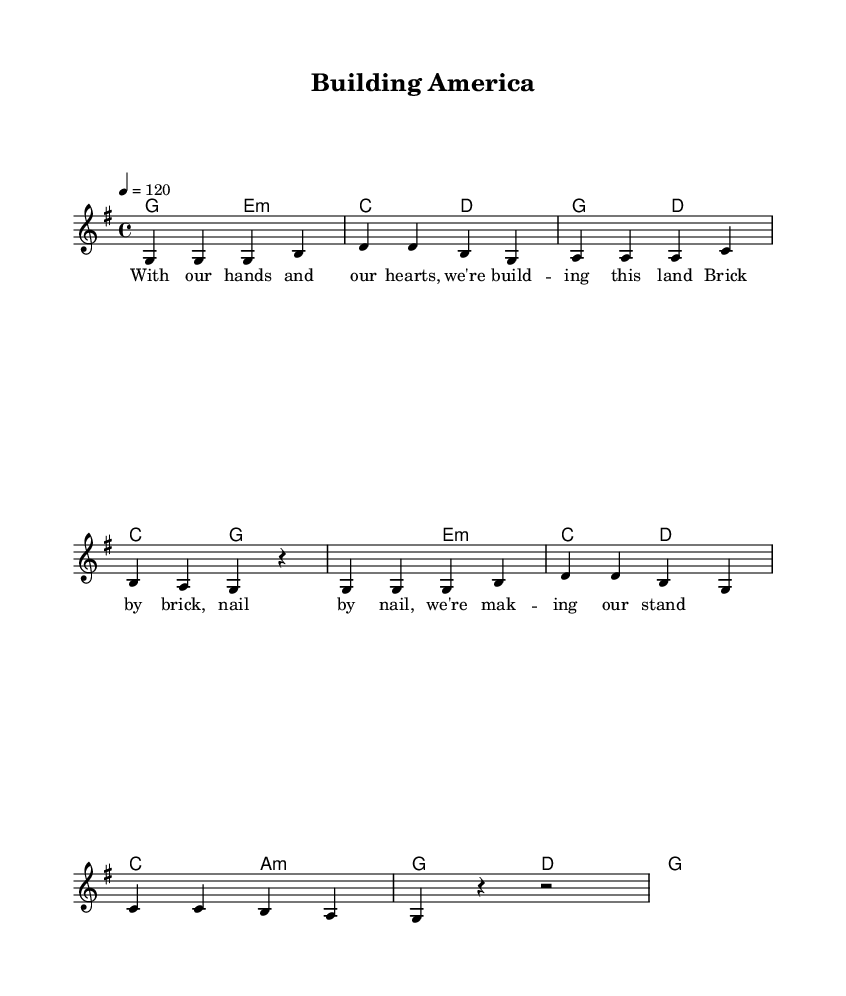What is the key signature of this music? The key signature is G major, which has one sharp (F#). This can be observed in the initial section of the sheet music where G major is indicated.
Answer: G major What is the time signature of this music? The time signature is 4/4, which means there are four beats in each measure (bar) and the quarter note gets one beat. This can be seen at the beginning of the score, specifically in the part where “\time 4/4” is stated.
Answer: 4/4 What is the tempo marking indicated in this music? The tempo marking is 120 beats per minute, as seen in the section stating “\tempo 4 = 120,” which indicates the speed of the piece.
Answer: 120 How many measures are there in the melody? There are 8 measures in the melody, as counted from the beginning of the melody notation until the end. Each measure is divided by vertical lines.
Answer: 8 What is the first chord in the harmony? The first chord in the harmony is G major, which is shown in the first part of the harmony section denoted as “g2” that signifies the G major chord.
Answer: G major What is the lyrical theme of the song? The theme celebrates craftsmanship and hard work in building the country, as seen in the lyrics “With our hands and our hearts, we're building this land.” This reflects the essence of the song's message.
Answer: Craftsmanship and hard work Which voice is carrying the melody in this score? The melody is carried by the voice labeled “melody,” which is explicitly indicated in the score as “\new Voice = 'melody'.” This shows the part that sings or plays the main melody line.
Answer: Melody 